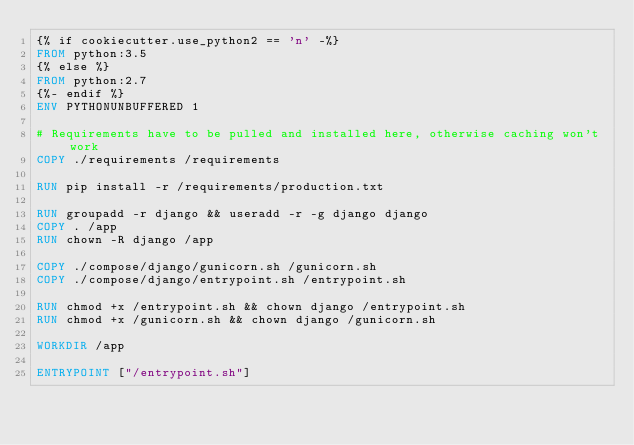<code> <loc_0><loc_0><loc_500><loc_500><_Dockerfile_>{% if cookiecutter.use_python2 == 'n' -%}
FROM python:3.5
{% else %}
FROM python:2.7
{%- endif %}
ENV PYTHONUNBUFFERED 1

# Requirements have to be pulled and installed here, otherwise caching won't work
COPY ./requirements /requirements

RUN pip install -r /requirements/production.txt

RUN groupadd -r django && useradd -r -g django django
COPY . /app
RUN chown -R django /app

COPY ./compose/django/gunicorn.sh /gunicorn.sh
COPY ./compose/django/entrypoint.sh /entrypoint.sh

RUN chmod +x /entrypoint.sh && chown django /entrypoint.sh
RUN chmod +x /gunicorn.sh && chown django /gunicorn.sh

WORKDIR /app

ENTRYPOINT ["/entrypoint.sh"]
</code> 